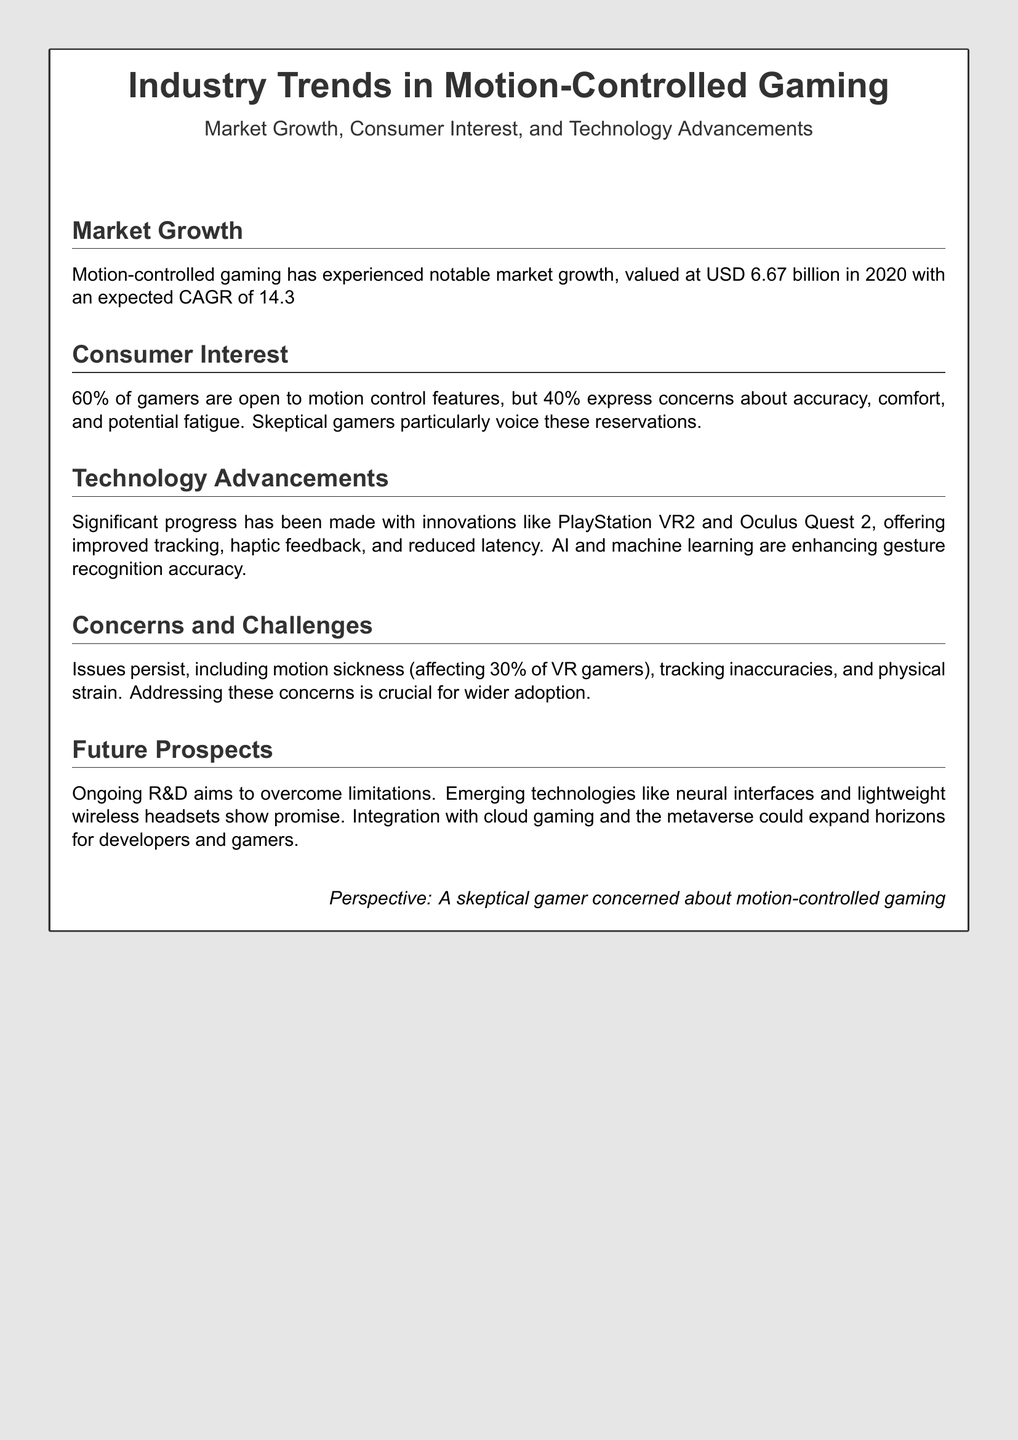What was the market value of motion-controlled gaming in 2020? The document states that the market was valued at USD 6.67 billion in 2020.
Answer: USD 6.67 billion What is the expected CAGR for motion-controlled gaming from 2021 to 2028? The document mentions an expected CAGR of 14.3% from 2021 to 2028.
Answer: 14.3% What percentage of gamers are open to motion control features? According to the document, 60% of gamers are open to motion control features.
Answer: 60% What is a major concern among skeptical gamers about motion-controlled gaming? The document highlights concerns about accuracy, comfort, and potential fatigue.
Answer: Accuracy What is one of the innovations mentioned in the document for technology advancements? The document lists significant progress with innovations like PlayStation VR2 and Oculus Quest 2.
Answer: PlayStation VR2 What percentage of VR gamers experience motion sickness? The document notes that 30% of VR gamers are affected by motion sickness.
Answer: 30% What emerging technology is mentioned that shows promise for the future of motion-controlled gaming? The document refers to neural interfaces as an emerging technology.
Answer: Neural interfaces What type of challenges are mentioned as crucial for wider adoption of motion-controlled gaming? The document describes challenges like motion sickness and tracking inaccuracies as crucial issues.
Answer: Tracking inaccuracies What type of document is this? The content and structure indicate that this is a Playbill on industry trends.
Answer: Playbill 